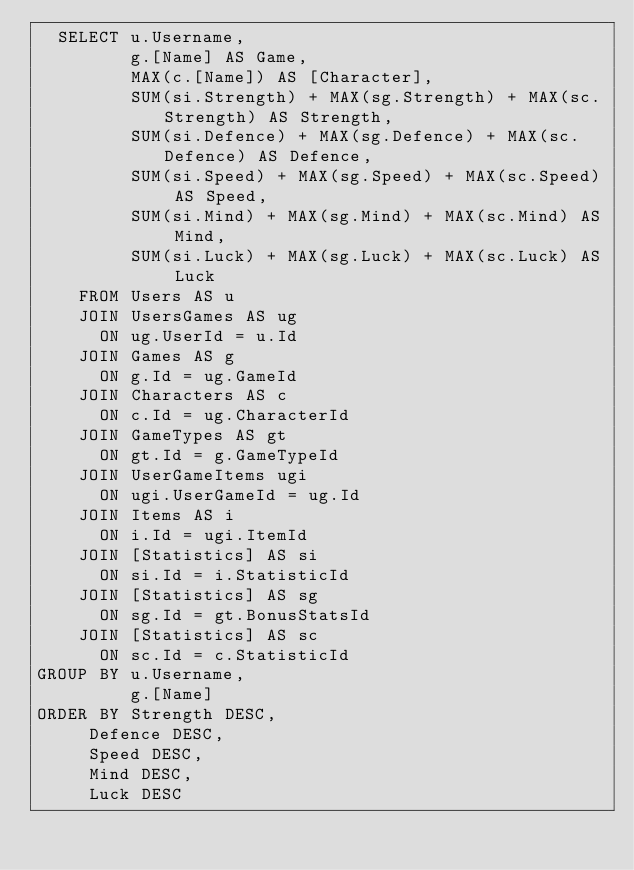Convert code to text. <code><loc_0><loc_0><loc_500><loc_500><_SQL_>  SELECT u.Username, 
  	     g.[Name] AS Game,
  	     MAX(c.[Name]) AS [Character],
  	     SUM(si.Strength) + MAX(sg.Strength) + MAX(sc.Strength) AS Strength,
  	     SUM(si.Defence) + MAX(sg.Defence) + MAX(sc.Defence) AS Defence,
  	     SUM(si.Speed) + MAX(sg.Speed) + MAX(sc.Speed) AS Speed,
  	     SUM(si.Mind) + MAX(sg.Mind) + MAX(sc.Mind) AS Mind,
  	     SUM(si.Luck) + MAX(sg.Luck) + MAX(sc.Luck) AS Luck
    FROM Users AS u
    JOIN UsersGames AS ug
      ON ug.UserId = u.Id
    JOIN Games AS g
      ON g.Id = ug.GameId
    JOIN Characters AS c
      ON c.Id = ug.CharacterId
    JOIN GameTypes AS gt
      ON gt.Id = g.GameTypeId
    JOIN UserGameItems ugi
      ON ugi.UserGameId = ug.Id
    JOIN Items AS i
      ON i.Id = ugi.ItemId
    JOIN [Statistics] AS si
      ON si.Id = i.StatisticId
    JOIN [Statistics] AS sg
      ON sg.Id = gt.BonusStatsId
    JOIN [Statistics] AS sc
      ON sc.Id = c.StatisticId
GROUP BY u.Username, 
         g.[Name]
ORDER BY Strength DESC, 
		 Defence DESC, 
		 Speed DESC, 
		 Mind DESC, 
		 Luck DESC</code> 